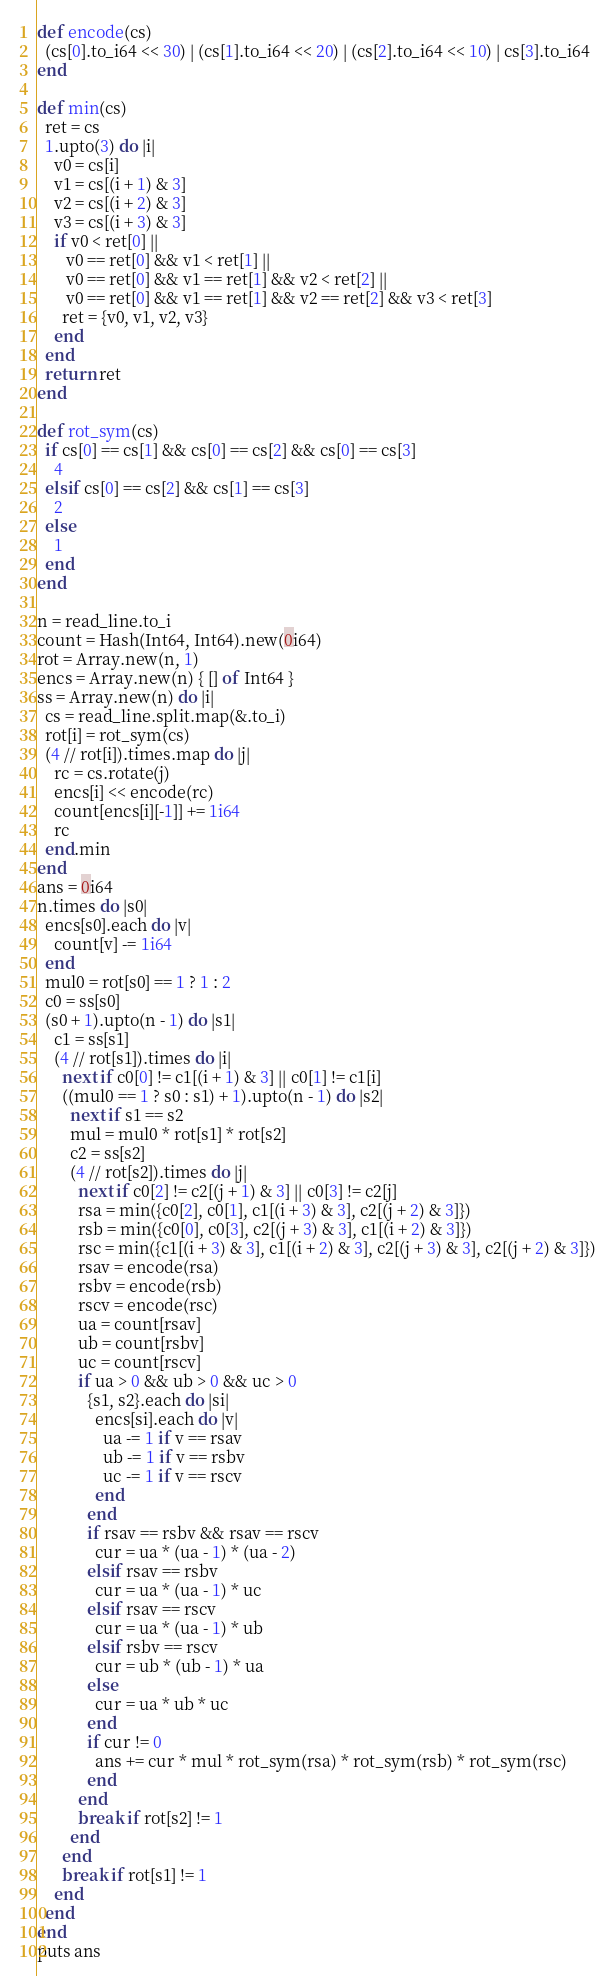<code> <loc_0><loc_0><loc_500><loc_500><_Crystal_>def encode(cs)
  (cs[0].to_i64 << 30) | (cs[1].to_i64 << 20) | (cs[2].to_i64 << 10) | cs[3].to_i64
end

def min(cs)
  ret = cs
  1.upto(3) do |i|
    v0 = cs[i]
    v1 = cs[(i + 1) & 3]
    v2 = cs[(i + 2) & 3]
    v3 = cs[(i + 3) & 3]
    if v0 < ret[0] ||
       v0 == ret[0] && v1 < ret[1] ||
       v0 == ret[0] && v1 == ret[1] && v2 < ret[2] ||
       v0 == ret[0] && v1 == ret[1] && v2 == ret[2] && v3 < ret[3]
      ret = {v0, v1, v2, v3}
    end
  end
  return ret
end

def rot_sym(cs)
  if cs[0] == cs[1] && cs[0] == cs[2] && cs[0] == cs[3]
    4
  elsif cs[0] == cs[2] && cs[1] == cs[3]
    2
  else
    1
  end
end

n = read_line.to_i
count = Hash(Int64, Int64).new(0i64)
rot = Array.new(n, 1)
encs = Array.new(n) { [] of Int64 }
ss = Array.new(n) do |i|
  cs = read_line.split.map(&.to_i)
  rot[i] = rot_sym(cs)
  (4 // rot[i]).times.map do |j|
    rc = cs.rotate(j)
    encs[i] << encode(rc)
    count[encs[i][-1]] += 1i64
    rc
  end.min
end
ans = 0i64
n.times do |s0|
  encs[s0].each do |v|
    count[v] -= 1i64
  end
  mul0 = rot[s0] == 1 ? 1 : 2
  c0 = ss[s0]
  (s0 + 1).upto(n - 1) do |s1|
    c1 = ss[s1]
    (4 // rot[s1]).times do |i|
      next if c0[0] != c1[(i + 1) & 3] || c0[1] != c1[i]
      ((mul0 == 1 ? s0 : s1) + 1).upto(n - 1) do |s2|
        next if s1 == s2
        mul = mul0 * rot[s1] * rot[s2]
        c2 = ss[s2]
        (4 // rot[s2]).times do |j|
          next if c0[2] != c2[(j + 1) & 3] || c0[3] != c2[j]
          rsa = min({c0[2], c0[1], c1[(i + 3) & 3], c2[(j + 2) & 3]})
          rsb = min({c0[0], c0[3], c2[(j + 3) & 3], c1[(i + 2) & 3]})
          rsc = min({c1[(i + 3) & 3], c1[(i + 2) & 3], c2[(j + 3) & 3], c2[(j + 2) & 3]})
          rsav = encode(rsa)
          rsbv = encode(rsb)
          rscv = encode(rsc)
          ua = count[rsav]
          ub = count[rsbv]
          uc = count[rscv]
          if ua > 0 && ub > 0 && uc > 0
            {s1, s2}.each do |si|
              encs[si].each do |v|
                ua -= 1 if v == rsav
                ub -= 1 if v == rsbv
                uc -= 1 if v == rscv
              end
            end
            if rsav == rsbv && rsav == rscv
              cur = ua * (ua - 1) * (ua - 2)
            elsif rsav == rsbv
              cur = ua * (ua - 1) * uc
            elsif rsav == rscv
              cur = ua * (ua - 1) * ub
            elsif rsbv == rscv
              cur = ub * (ub - 1) * ua
            else
              cur = ua * ub * uc
            end
            if cur != 0
              ans += cur * mul * rot_sym(rsa) * rot_sym(rsb) * rot_sym(rsc)
            end
          end
          break if rot[s2] != 1
        end
      end
      break if rot[s1] != 1
    end
  end
end
puts ans
</code> 